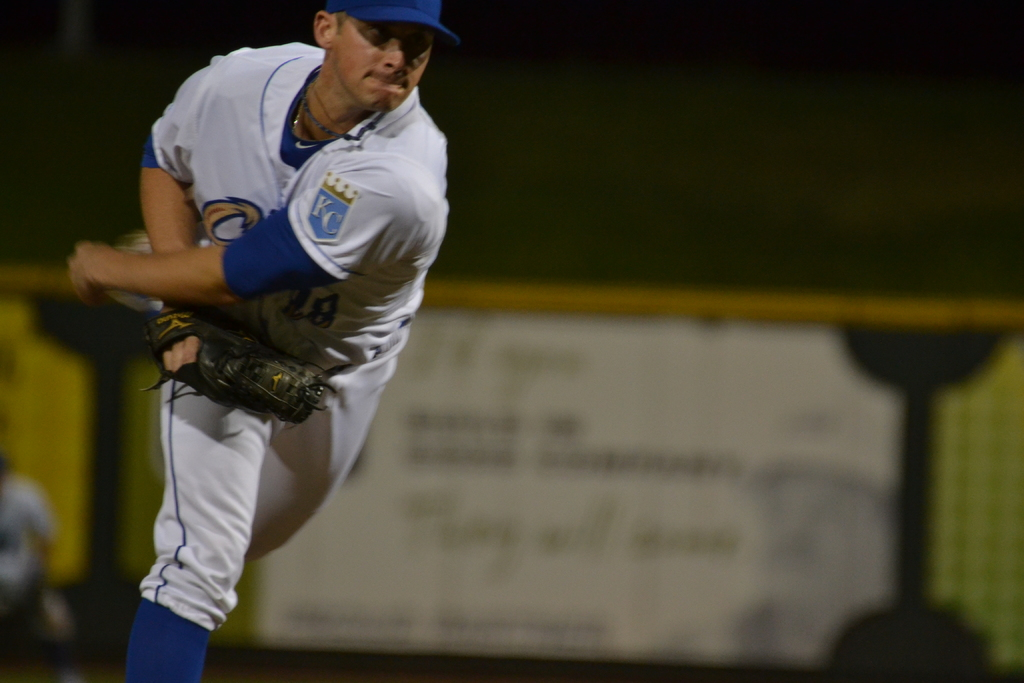Provide a one-sentence caption for the provided image.
Reference OCR token:  An athlete mid throw with a KC emblem on his left shoulder. 